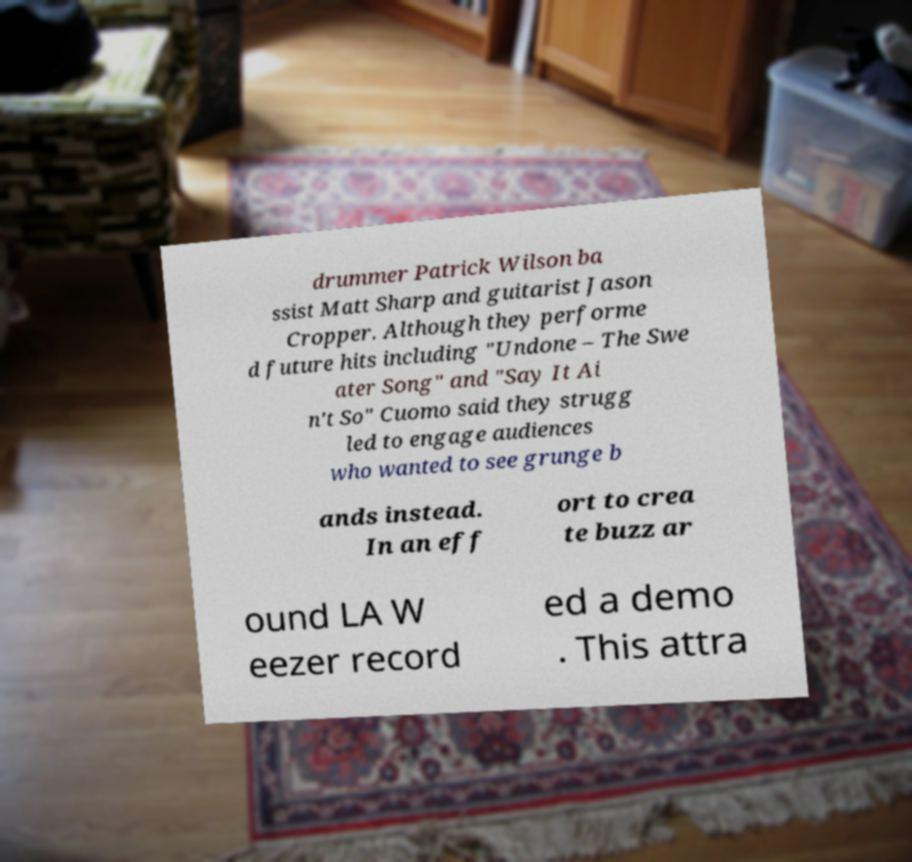For documentation purposes, I need the text within this image transcribed. Could you provide that? drummer Patrick Wilson ba ssist Matt Sharp and guitarist Jason Cropper. Although they performe d future hits including "Undone – The Swe ater Song" and "Say It Ai n't So" Cuomo said they strugg led to engage audiences who wanted to see grunge b ands instead. In an eff ort to crea te buzz ar ound LA W eezer record ed a demo . This attra 